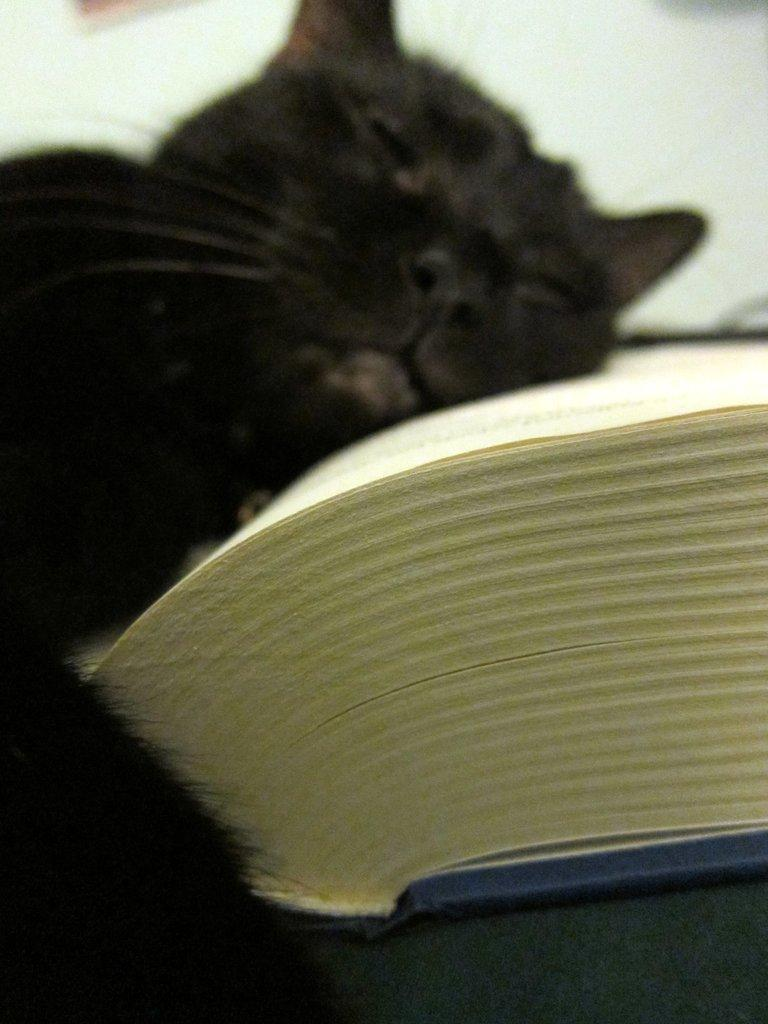What type of creature is present in the image? There is an animal in the image. What is the animal doing in the image? The animal is sleeping on a book. What is the color of the animal in the image? The animal is black in color. What type of peace treaty is being signed by the animal in the image? There is no peace treaty or signing event depicted in the image; the animal is simply sleeping on a book. 